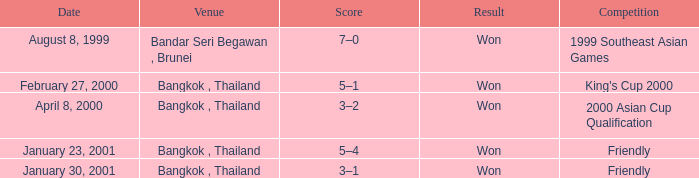On which date did the match with a 7-0 score take place? August 8, 1999. 